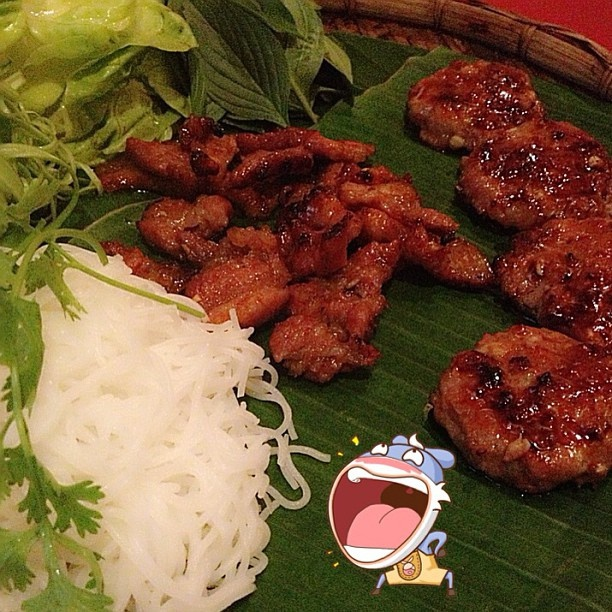Describe the objects in this image and their specific colors. I can see various objects in this image with different colors. 